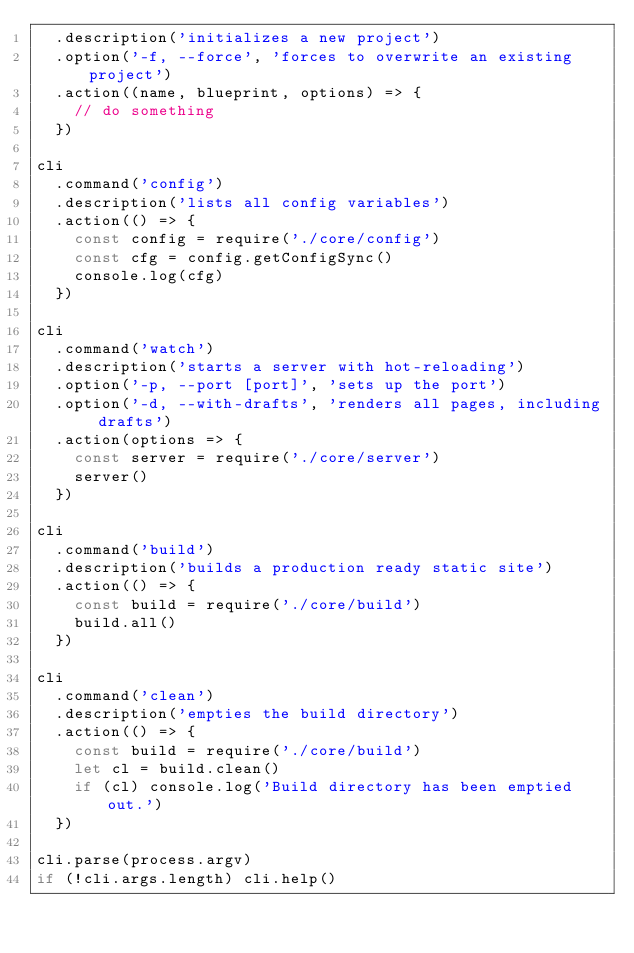<code> <loc_0><loc_0><loc_500><loc_500><_JavaScript_>  .description('initializes a new project')
  .option('-f, --force', 'forces to overwrite an existing project')
  .action((name, blueprint, options) => {
    // do something
  })

cli
  .command('config')
  .description('lists all config variables')
  .action(() => {
    const config = require('./core/config')
    const cfg = config.getConfigSync()
    console.log(cfg)
  })

cli
  .command('watch')
  .description('starts a server with hot-reloading')
  .option('-p, --port [port]', 'sets up the port')
  .option('-d, --with-drafts', 'renders all pages, including drafts')
  .action(options => {
    const server = require('./core/server')
    server()
  })

cli
  .command('build')
  .description('builds a production ready static site')
  .action(() => {
    const build = require('./core/build')
    build.all()
  })

cli
  .command('clean')
  .description('empties the build directory')
  .action(() => {
    const build = require('./core/build')
    let cl = build.clean()
    if (cl) console.log('Build directory has been emptied out.')
  })

cli.parse(process.argv)
if (!cli.args.length) cli.help()
</code> 